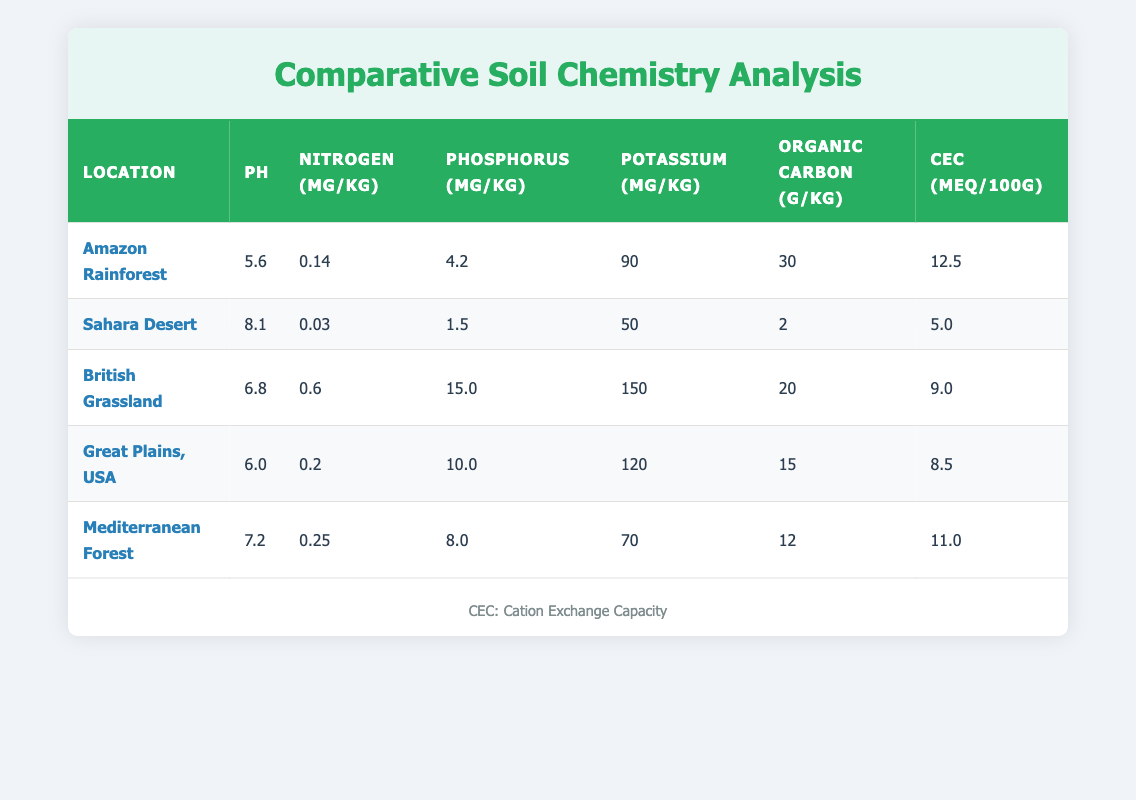What is the pH level of the Sahara Desert? From the table, locate the row for the Sahara Desert, and look under the pH column. The value listed is 8.1.
Answer: 8.1 Which location has the highest nitrogen content? By examining the nitrogen content values in the table, the highest value is found in the British Grassland, which is 0.6 mg/kg.
Answer: British Grassland What is the average potassium content of the sampled areas? Summing the potassium content values: (90 + 50 + 150 + 120 + 70) = 480. There are 5 locations, so the average is 480/5 = 96.
Answer: 96 Is the organic carbon content in the Amazon Rainforest higher than in the Sahara Desert? The organic carbon content in the Amazon Rainforest is 30 g/kg, and in the Sahara Desert, it is 2 g/kg. Since 30 is greater than 2, the statement is true.
Answer: Yes Which location has the lowest cation exchange capacity? By checking the cation exchange capacity column for the minimum value, Sahara Desert shows the lowest at 5.0 meq/100g.
Answer: Sahara Desert What is the difference in phosphorus content between the British Grassland and the Mediterranean Forest? The phosphorus content in the British Grassland is 15.0 mg/kg and in the Mediterranean Forest, it is 8.0 mg/kg. Therefore, the difference is 15.0 - 8.0 = 7.0 mg/kg.
Answer: 7.0 In terms of pH levels, which two locations exhibit the closest values? Reviewing the pH values: Amazon Rainforest (5.6), British Grassland (6.8), Great Plains (6.0), Mediterranean Forest (7.2), and Sahara Desert (8.1). The closest values are between Great Plains (6.0) and British Grassland (6.8), with a difference of 0.8.
Answer: Great Plains and British Grassland Are all sampled areas below a pH of 7 considered acidic? Assessing pH levels: Amazon Rainforest (5.6), British Grassland (6.8), Great Plains (6.0), and Mediterranean Forest (7.2) are below 7, and the Sahara Desert (8.1) is alkaline. Since one is above 7, the statement is false.
Answer: No 